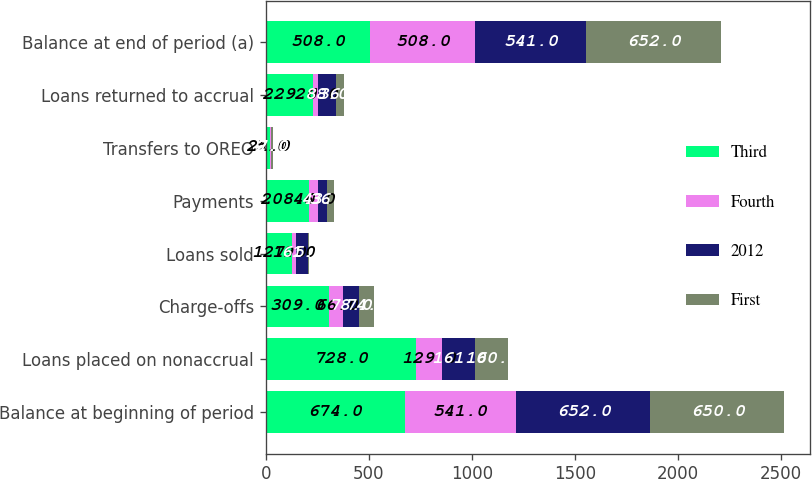<chart> <loc_0><loc_0><loc_500><loc_500><stacked_bar_chart><ecel><fcel>Balance at beginning of period<fcel>Loans placed on nonaccrual<fcel>Charge-offs<fcel>Loans sold<fcel>Payments<fcel>Transfers to OREO<fcel>Loans returned to accrual<fcel>Balance at end of period (a)<nl><fcel>Third<fcel>674<fcel>728<fcel>309<fcel>127<fcel>208<fcel>21<fcel>229<fcel>508<nl><fcel>Fourth<fcel>541<fcel>129<fcel>66<fcel>19<fcel>46<fcel>5<fcel>26<fcel>508<nl><fcel>2012<fcel>652<fcel>161<fcel>78<fcel>61<fcel>43<fcel>2<fcel>88<fcel>541<nl><fcel>First<fcel>650<fcel>160<fcel>74<fcel>5<fcel>36<fcel>7<fcel>36<fcel>652<nl></chart> 